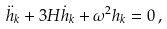Convert formula to latex. <formula><loc_0><loc_0><loc_500><loc_500>\ddot { h } _ { k } + 3 H \dot { h } _ { k } + \omega ^ { 2 } h _ { k } = 0 \, ,</formula> 